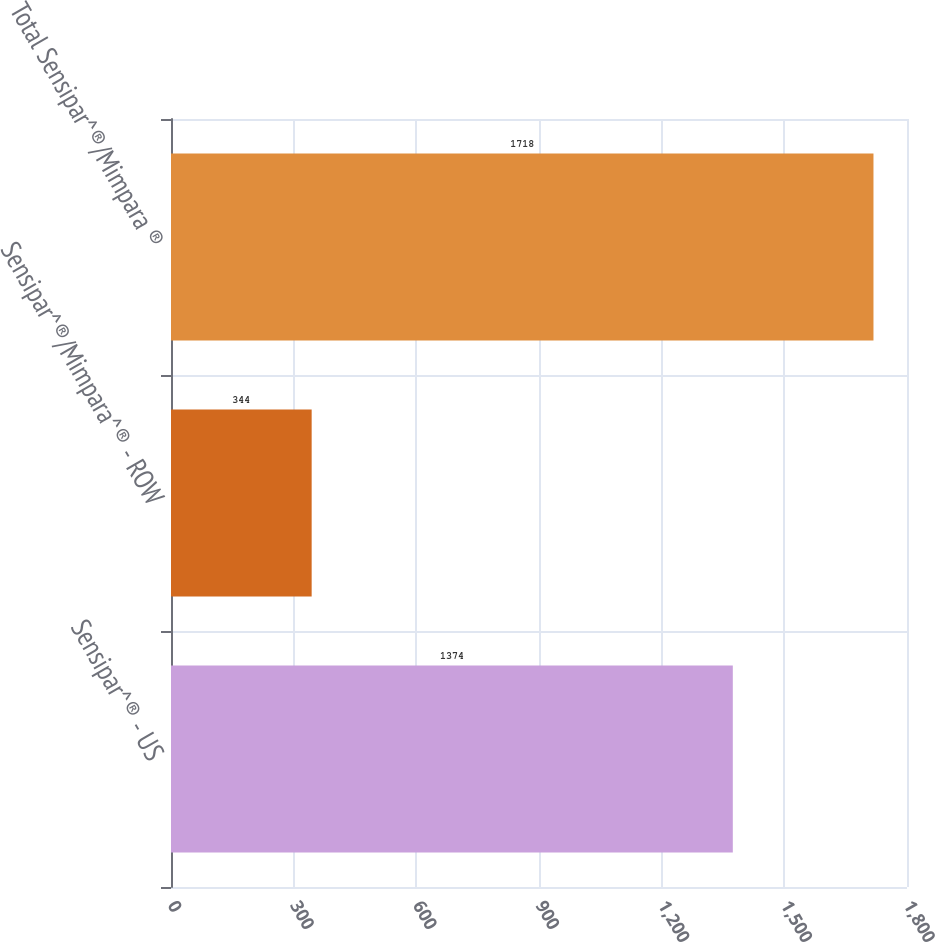Convert chart to OTSL. <chart><loc_0><loc_0><loc_500><loc_500><bar_chart><fcel>Sensipar^® - US<fcel>Sensipar^®/Mimpara^® - ROW<fcel>Total Sensipar^®/Mimpara ®<nl><fcel>1374<fcel>344<fcel>1718<nl></chart> 